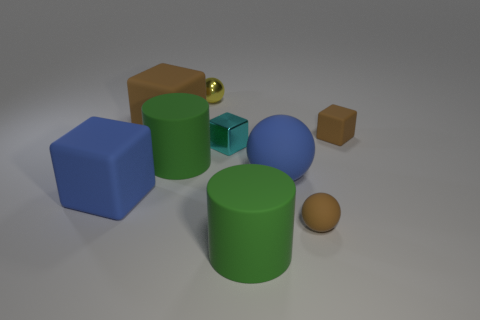There is a blue cube; are there any tiny matte objects behind it?
Ensure brevity in your answer.  Yes. Is the shape of the cyan metallic thing the same as the green rubber thing on the right side of the yellow metal sphere?
Make the answer very short. No. How many other objects are the same material as the blue sphere?
Keep it short and to the point. 6. What is the color of the sphere in front of the big blue rubber object that is to the right of the small yellow ball behind the large blue block?
Make the answer very short. Brown. What shape is the green object that is on the right side of the small object that is behind the tiny brown block?
Your answer should be compact. Cylinder. Is the number of cylinders that are in front of the tiny matte block greater than the number of small shiny cubes?
Offer a terse response. Yes. Does the tiny brown matte thing that is in front of the big blue matte cube have the same shape as the tiny yellow metallic thing?
Provide a succinct answer. Yes. Are there any tiny brown matte objects that have the same shape as the yellow object?
Offer a terse response. Yes. How many things are green rubber objects in front of the brown ball or tiny cyan metal blocks?
Provide a succinct answer. 2. Are there more small rubber things than tiny cyan cubes?
Make the answer very short. Yes. 